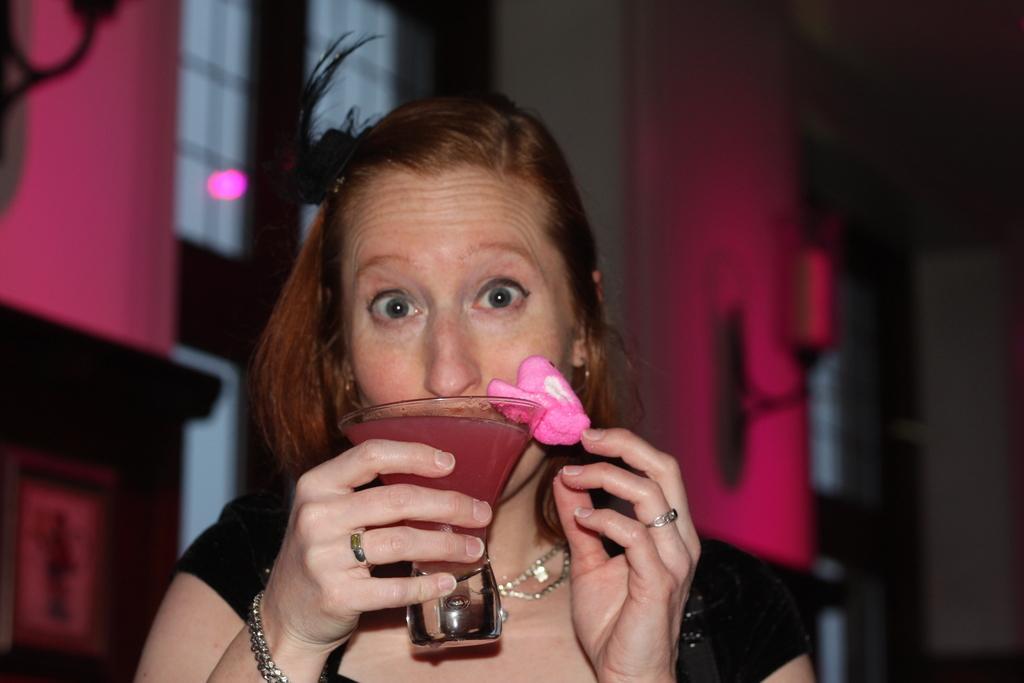Could you give a brief overview of what you see in this image? In this image in the front there is a woman holding a glass. In the background there is a wall and on the wall there are light lamps and windows and there is a cupboard in front of the wall. 